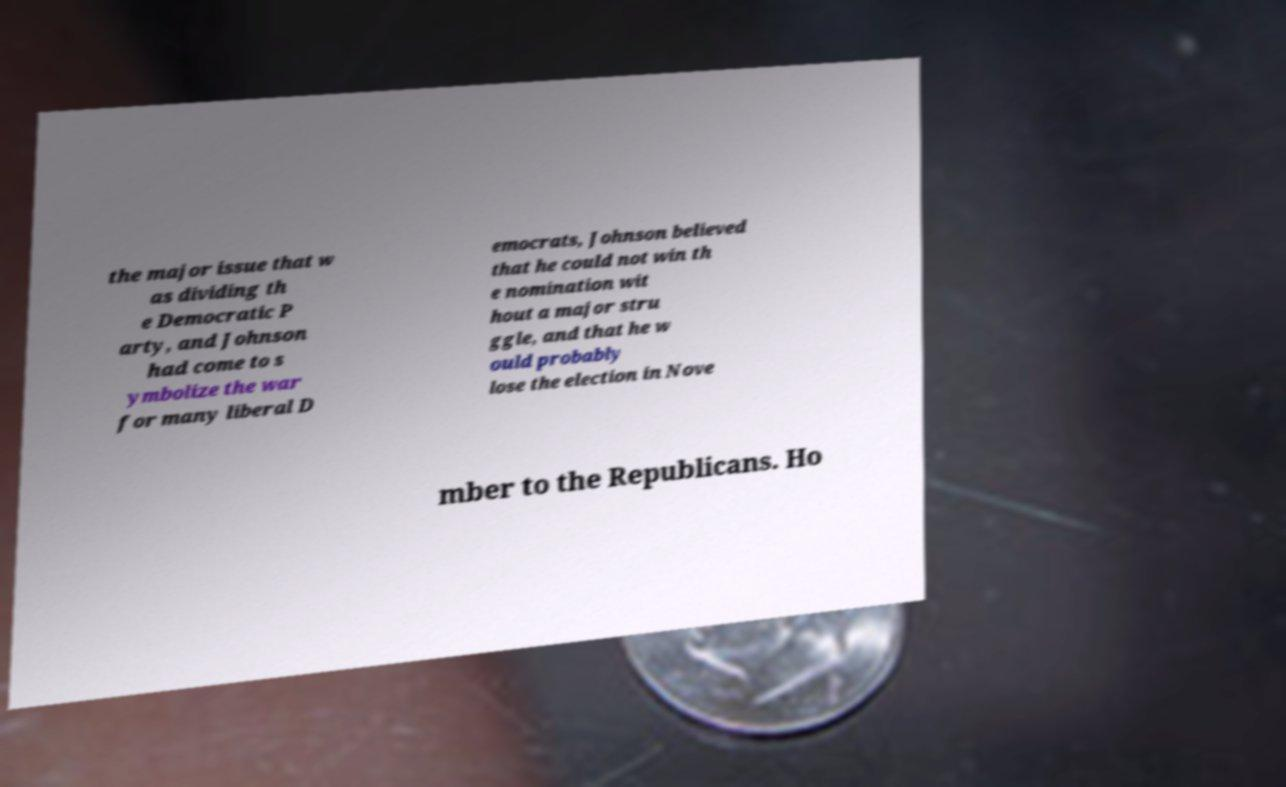Can you read and provide the text displayed in the image?This photo seems to have some interesting text. Can you extract and type it out for me? the major issue that w as dividing th e Democratic P arty, and Johnson had come to s ymbolize the war for many liberal D emocrats, Johnson believed that he could not win th e nomination wit hout a major stru ggle, and that he w ould probably lose the election in Nove mber to the Republicans. Ho 